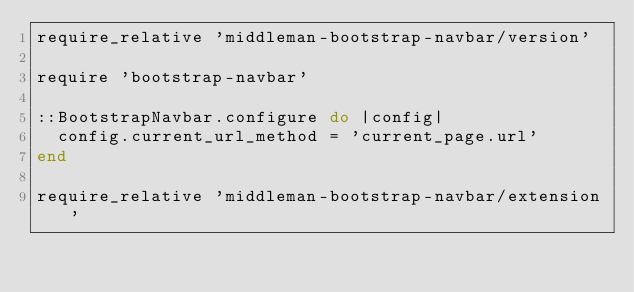<code> <loc_0><loc_0><loc_500><loc_500><_Ruby_>require_relative 'middleman-bootstrap-navbar/version'

require 'bootstrap-navbar'

::BootstrapNavbar.configure do |config|
  config.current_url_method = 'current_page.url'
end

require_relative 'middleman-bootstrap-navbar/extension'
</code> 